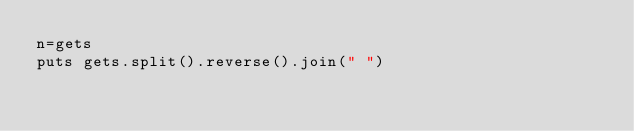<code> <loc_0><loc_0><loc_500><loc_500><_Ruby_>n=gets
puts gets.split().reverse().join(" ")</code> 